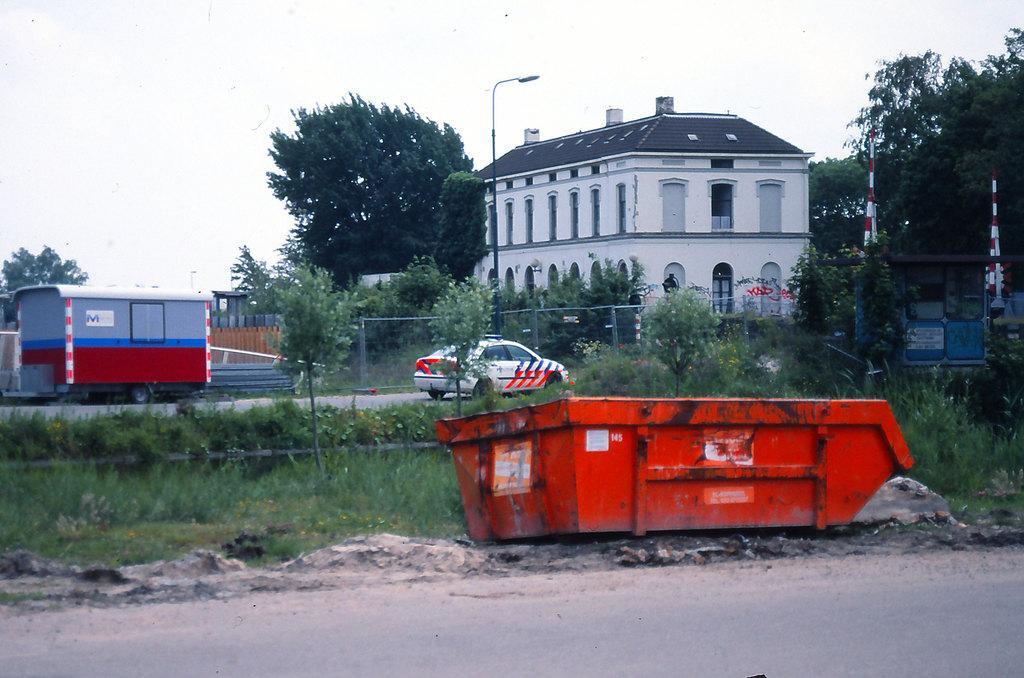In one or two sentences, can you explain what this image depicts? At the bottom of this image, there is a road. In the background, there is an orange color object, there are trees, two vehicles on a road, a building, poles, plants and grass on the ground and there are clouds in the sky. 